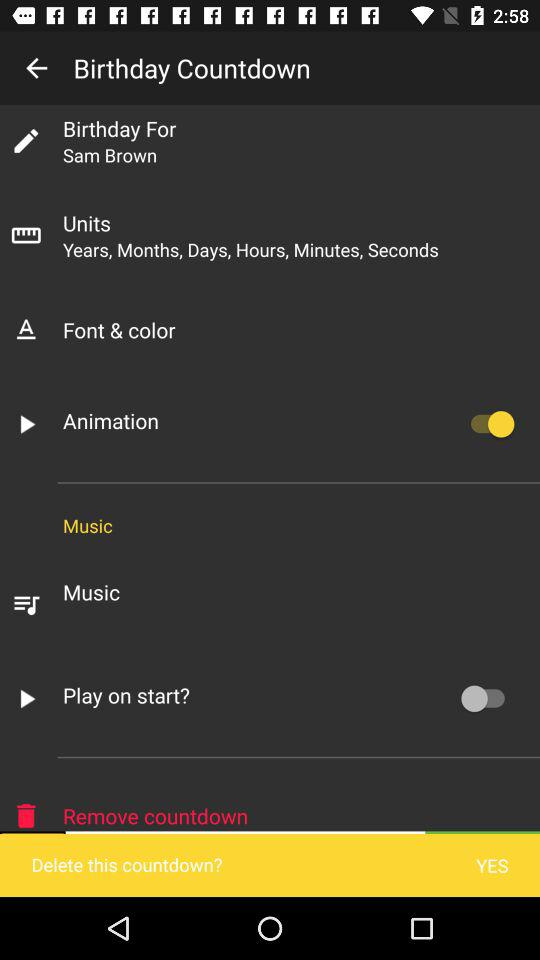What are the units given in the "Birthday Countdown"? The given units are years, months, days, hours, minutes and seconds. 